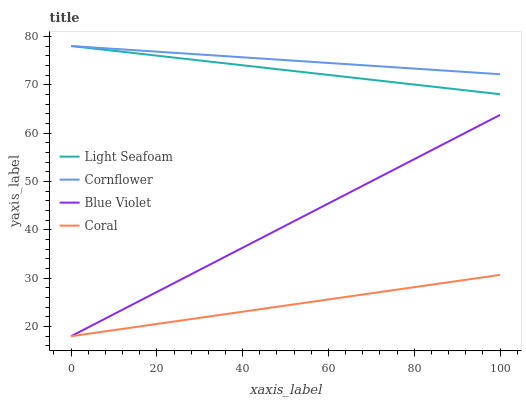Does Coral have the minimum area under the curve?
Answer yes or no. Yes. Does Cornflower have the maximum area under the curve?
Answer yes or no. Yes. Does Light Seafoam have the minimum area under the curve?
Answer yes or no. No. Does Light Seafoam have the maximum area under the curve?
Answer yes or no. No. Is Coral the smoothest?
Answer yes or no. Yes. Is Light Seafoam the roughest?
Answer yes or no. Yes. Is Light Seafoam the smoothest?
Answer yes or no. No. Is Coral the roughest?
Answer yes or no. No. Does Light Seafoam have the lowest value?
Answer yes or no. No. Does Coral have the highest value?
Answer yes or no. No. Is Coral less than Light Seafoam?
Answer yes or no. Yes. Is Light Seafoam greater than Coral?
Answer yes or no. Yes. Does Coral intersect Light Seafoam?
Answer yes or no. No. 